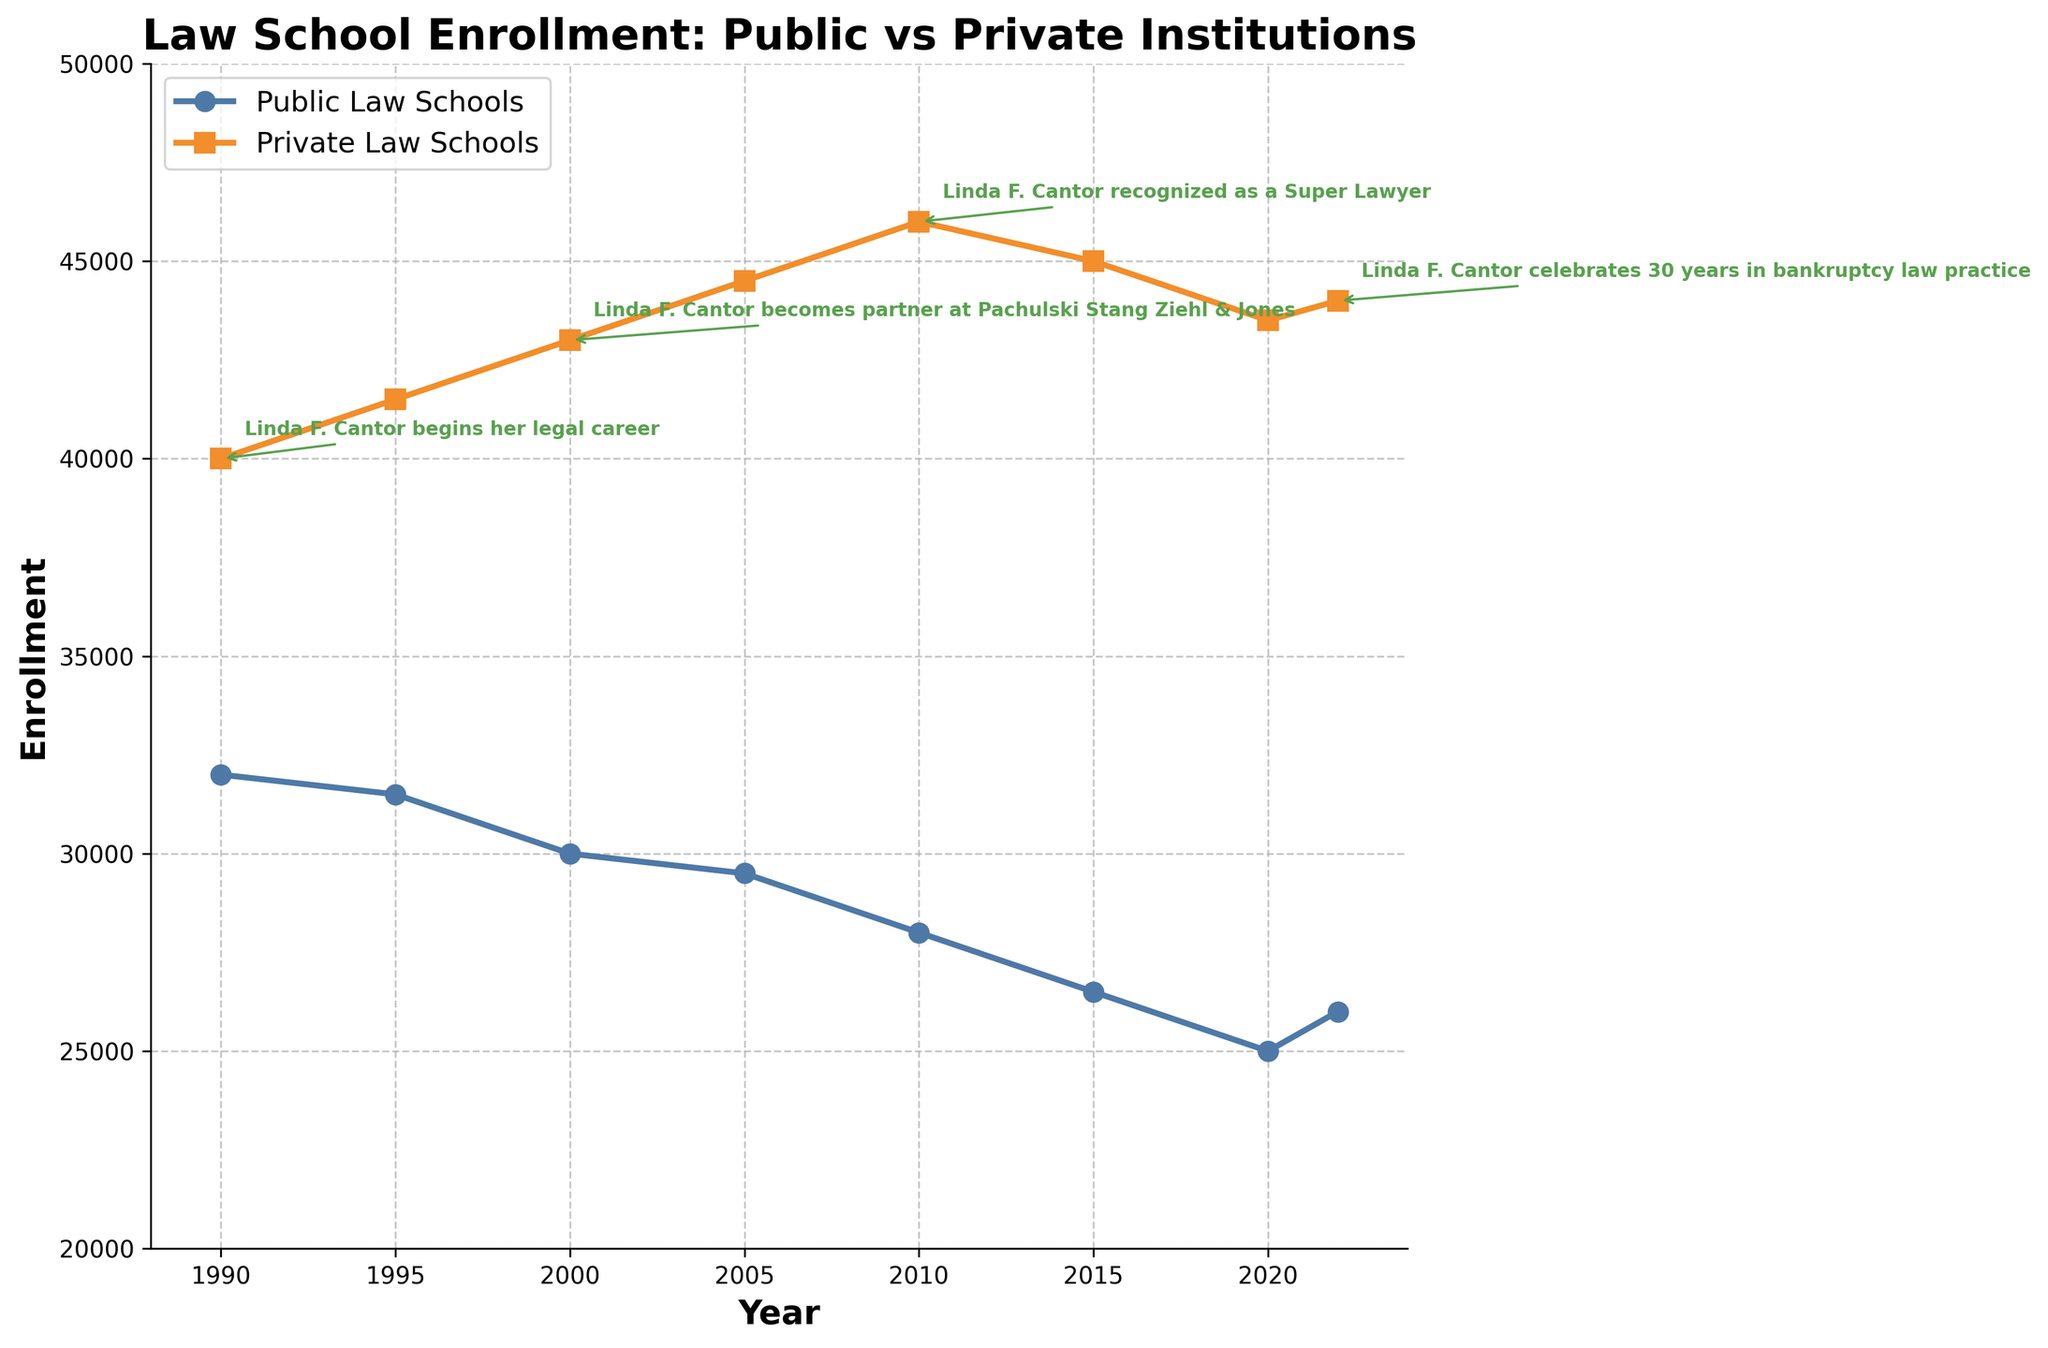How do the enrollment numbers for public and private law schools compare in 1990? The figure shows enrollment numbers for both public and private law schools in 1990. Looking at the data points for that year, public schools had an enrollment of 32,000, while private schools had 40,000. Comparing these numbers reveals that private law schools had higher enrollment in 1990.
Answer: Private law schools had higher enrollment What is the overall trend in enrollment for public law schools from 1990 to 2022? Examine the line chart for public law school enrollment. The trend starts at 32,000 in 1990 and shows a general decline, reaching 26,000 in 2022. The enrollment numbers slowly decrease over the years, indicating a downward trend.
Answer: Downward trend Which year had the highest enrollment for private law schools, and what was the enrollment number? From the line chart, the peak for private law school enrollment seems to occur around the year 2010. The data point shows an enrollment of 46,000 in that year.
Answer: 2010, 46,000 How much did the enrollment in public law schools decrease from 1990 to 2020? The enrollment number for public law schools in 1990 was 32,000 and it decreased to 25,000 by 2020. Subtract the 2020 number from the 1990 number: 32,000 - 25,000 = 7,000.
Answer: 7,000 Were there any years when the enrollment numbers for public law schools increased? Check the line chart for any upward movements in the public law school enrollment line. There is an increase from 2020 (25,000) to 2022 (26,000). These years are the only ones showing an increase.
Answer: Yes, 2020 to 2022 How did the enrollment changes in public law schools from 2010 to 2015 compare to those in private law schools? From the line chart, the enrollment for public law schools decreased from 28,000 in 2010 to 26,500 in 2015, a drop of 1,500. For private law schools, the enrollment decreased from 46,000 in 2010 to 45,000 in 2015, a drop of 1,000. Public law schools experienced a larger decrease in enrollment.
Answer: Public law schools had a larger decrease What notable event in Linda F. Cantor's career occurred when public law school enrollment was approximately 30,000? According to the annotation and the line chart, Linda F. Cantor became a partner at Pachulski Stang Ziehl & Jones in 2000 when public law school enrollment was around 30,000.
Answer: Became partner at Pachulski Stang Ziehl & Jones How does the color of the lines help distinguish between public and private law schools? The line chart uses different colors for the lines representing public and private law schools: public law schools are represented in blue, and private law schools in orange. This visual distinction helps easily differentiate between the two categories.
Answer: Blue for public, orange for private What is the overall difference in enrollment between public and private law schools in 2022? In 2022, the enrollment for public law schools was 26,000 and for private law schools was 44,000. The difference between these numbers is 44,000 - 26,000 = 18,000.
Answer: 18,000 